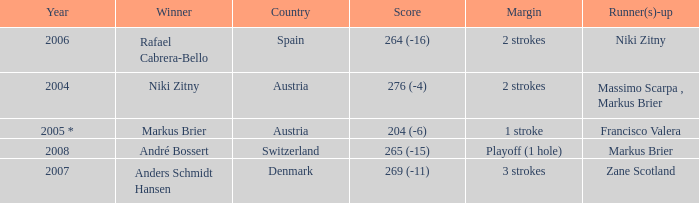What was the country when the margin was 2 strokes, and when the score was 276 (-4)? Austria. 